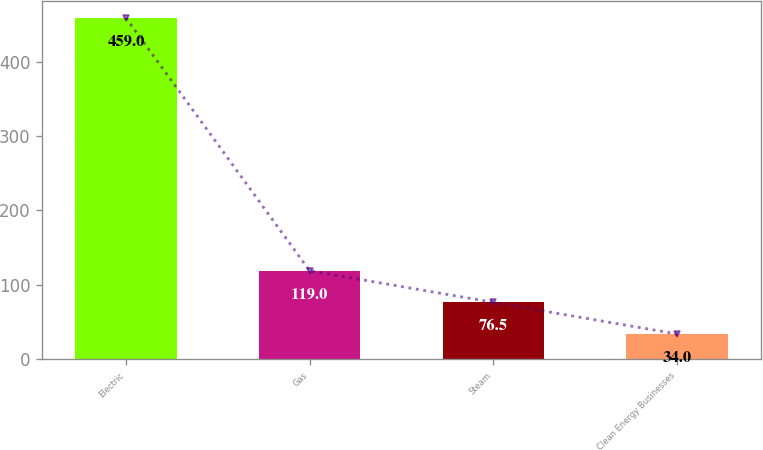Convert chart. <chart><loc_0><loc_0><loc_500><loc_500><bar_chart><fcel>Electric<fcel>Gas<fcel>Steam<fcel>Clean Energy Businesses<nl><fcel>459<fcel>119<fcel>76.5<fcel>34<nl></chart> 